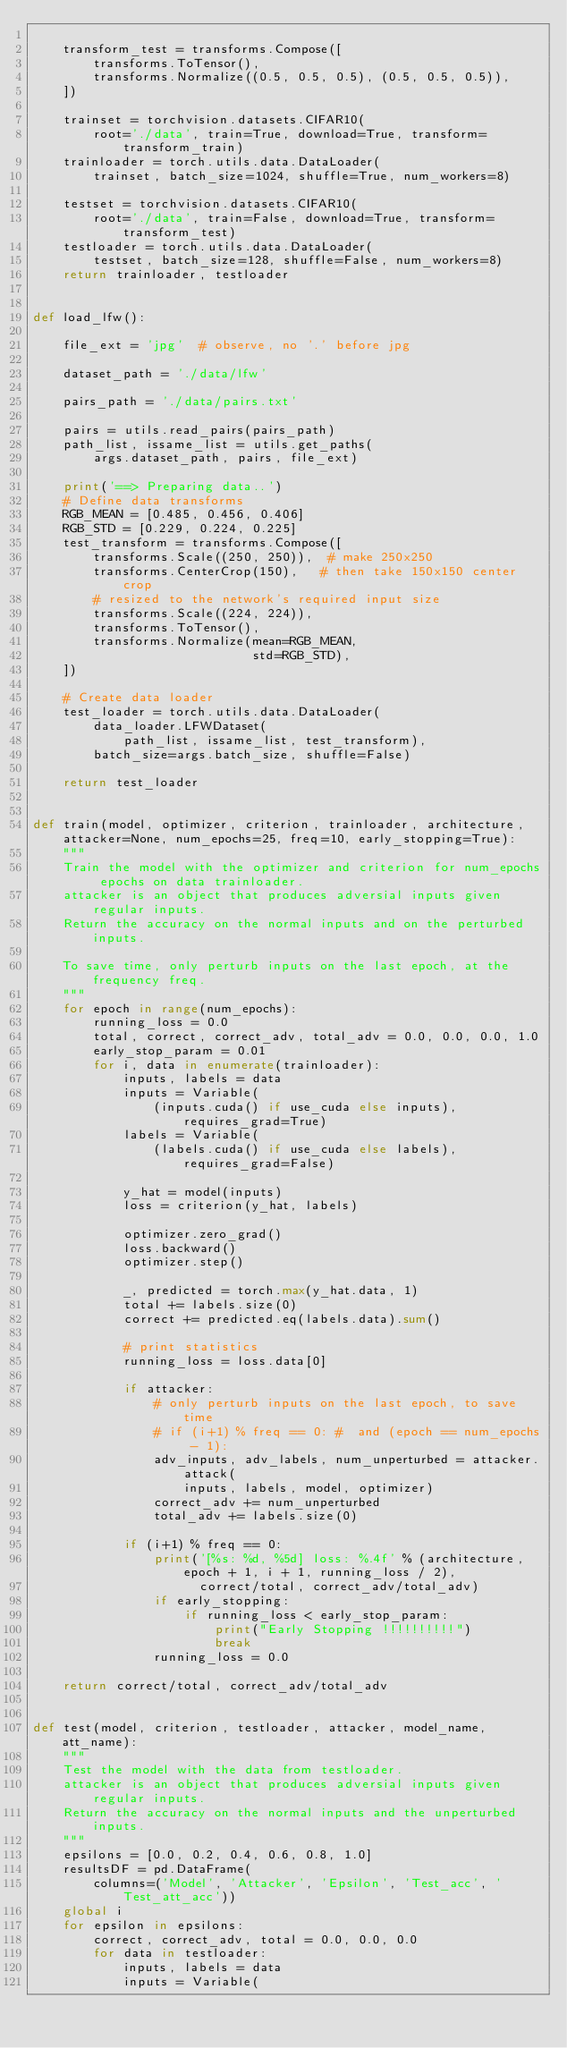<code> <loc_0><loc_0><loc_500><loc_500><_Python_>
    transform_test = transforms.Compose([
        transforms.ToTensor(),
        transforms.Normalize((0.5, 0.5, 0.5), (0.5, 0.5, 0.5)),
    ])

    trainset = torchvision.datasets.CIFAR10(
        root='./data', train=True, download=True, transform=transform_train)
    trainloader = torch.utils.data.DataLoader(
        trainset, batch_size=1024, shuffle=True, num_workers=8)

    testset = torchvision.datasets.CIFAR10(
        root='./data', train=False, download=True, transform=transform_test)
    testloader = torch.utils.data.DataLoader(
        testset, batch_size=128, shuffle=False, num_workers=8)
    return trainloader, testloader


def load_lfw():

    file_ext = 'jpg'  # observe, no '.' before jpg

    dataset_path = './data/lfw'

    pairs_path = './data/pairs.txt'

    pairs = utils.read_pairs(pairs_path)
    path_list, issame_list = utils.get_paths(
        args.dataset_path, pairs, file_ext)

    print('==> Preparing data..')
    # Define data transforms
    RGB_MEAN = [0.485, 0.456, 0.406]
    RGB_STD = [0.229, 0.224, 0.225]
    test_transform = transforms.Compose([
        transforms.Scale((250, 250)),  # make 250x250
        transforms.CenterCrop(150),   # then take 150x150 center crop
        # resized to the network's required input size
        transforms.Scale((224, 224)),
        transforms.ToTensor(),
        transforms.Normalize(mean=RGB_MEAN,
                             std=RGB_STD),
    ])

    # Create data loader
    test_loader = torch.utils.data.DataLoader(
        data_loader.LFWDataset(
            path_list, issame_list, test_transform),
        batch_size=args.batch_size, shuffle=False)

    return test_loader


def train(model, optimizer, criterion, trainloader, architecture, attacker=None, num_epochs=25, freq=10, early_stopping=True):
    """
    Train the model with the optimizer and criterion for num_epochs epochs on data trainloader.
    attacker is an object that produces adversial inputs given regular inputs.
    Return the accuracy on the normal inputs and on the perturbed inputs.

    To save time, only perturb inputs on the last epoch, at the frequency freq.
    """
    for epoch in range(num_epochs):
        running_loss = 0.0
        total, correct, correct_adv, total_adv = 0.0, 0.0, 0.0, 1.0
        early_stop_param = 0.01
        for i, data in enumerate(trainloader):
            inputs, labels = data
            inputs = Variable(
                (inputs.cuda() if use_cuda else inputs), requires_grad=True)
            labels = Variable(
                (labels.cuda() if use_cuda else labels), requires_grad=False)

            y_hat = model(inputs)
            loss = criterion(y_hat, labels)

            optimizer.zero_grad()
            loss.backward()
            optimizer.step()

            _, predicted = torch.max(y_hat.data, 1)
            total += labels.size(0)
            correct += predicted.eq(labels.data).sum()

            # print statistics
            running_loss = loss.data[0]

            if attacker:
                # only perturb inputs on the last epoch, to save time
                # if (i+1) % freq == 0: #  and (epoch == num_epochs - 1):
                adv_inputs, adv_labels, num_unperturbed = attacker.attack(
                    inputs, labels, model, optimizer)
                correct_adv += num_unperturbed
                total_adv += labels.size(0)

            if (i+1) % freq == 0:
                print('[%s: %d, %5d] loss: %.4f' % (architecture, epoch + 1, i + 1, running_loss / 2),
                      correct/total, correct_adv/total_adv)
                if early_stopping:
                    if running_loss < early_stop_param:
                        print("Early Stopping !!!!!!!!!!")
                        break
                running_loss = 0.0

    return correct/total, correct_adv/total_adv


def test(model, criterion, testloader, attacker, model_name, att_name):
    """
    Test the model with the data from testloader.
    attacker is an object that produces adversial inputs given regular inputs.
    Return the accuracy on the normal inputs and the unperturbed inputs.
    """
    epsilons = [0.0, 0.2, 0.4, 0.6, 0.8, 1.0]
    resultsDF = pd.DataFrame(
        columns=('Model', 'Attacker', 'Epsilon', 'Test_acc', 'Test_att_acc'))
    global i
    for epsilon in epsilons:
        correct, correct_adv, total = 0.0, 0.0, 0.0
        for data in testloader:
            inputs, labels = data
            inputs = Variable(</code> 